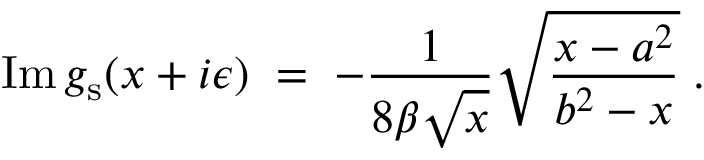<formula> <loc_0><loc_0><loc_500><loc_500>I m \, g _ { s } ( x + i \epsilon ) \, = \, - { \frac { 1 } { 8 \beta \sqrt { x } } } \sqrt { { \frac { x - a ^ { 2 } } { b ^ { 2 } - x } } } \, .</formula> 